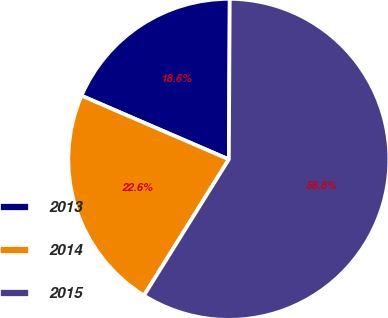<chart> <loc_0><loc_0><loc_500><loc_500><pie_chart><fcel>2013<fcel>2014<fcel>2015<nl><fcel>18.6%<fcel>22.62%<fcel>58.78%<nl></chart> 